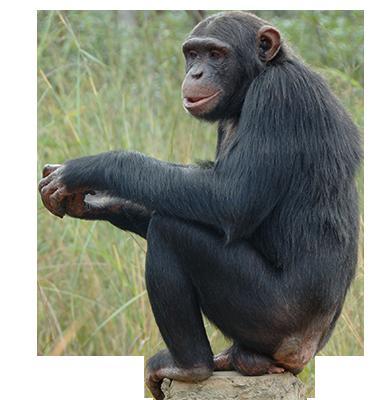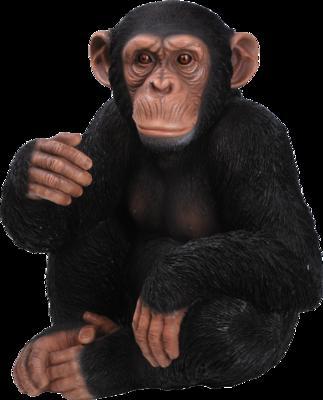The first image is the image on the left, the second image is the image on the right. Evaluate the accuracy of this statement regarding the images: "A primate is being shown against a black background.". Is it true? Answer yes or no. Yes. The first image is the image on the left, the second image is the image on the right. Analyze the images presented: Is the assertion "Each image shows exactly one chimpanzee, with at least one of its hands touching part of its body." valid? Answer yes or no. Yes. 